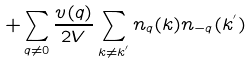Convert formula to latex. <formula><loc_0><loc_0><loc_500><loc_500>+ \sum _ { { q } \neq 0 } \frac { v ( { q } ) } { 2 V } \sum _ { { k } \neq { k } ^ { ^ { \prime } } } n _ { q } ( { k } ) n _ { - { q } } ( { k } ^ { ^ { \prime } } )</formula> 